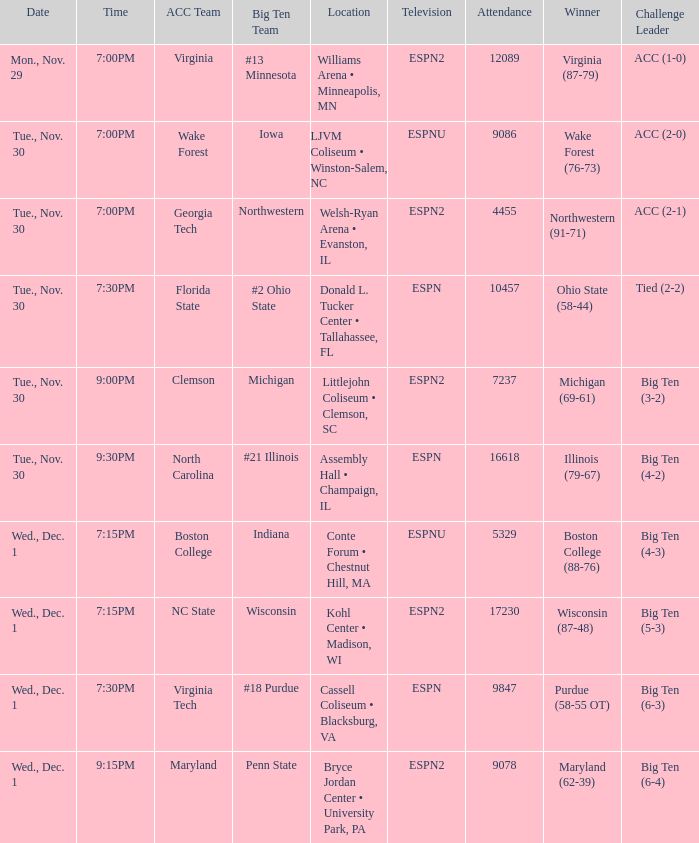Who were the leading contenders in the games boston college triumphed in with a score of 88-76? Big Ten (4-3). 